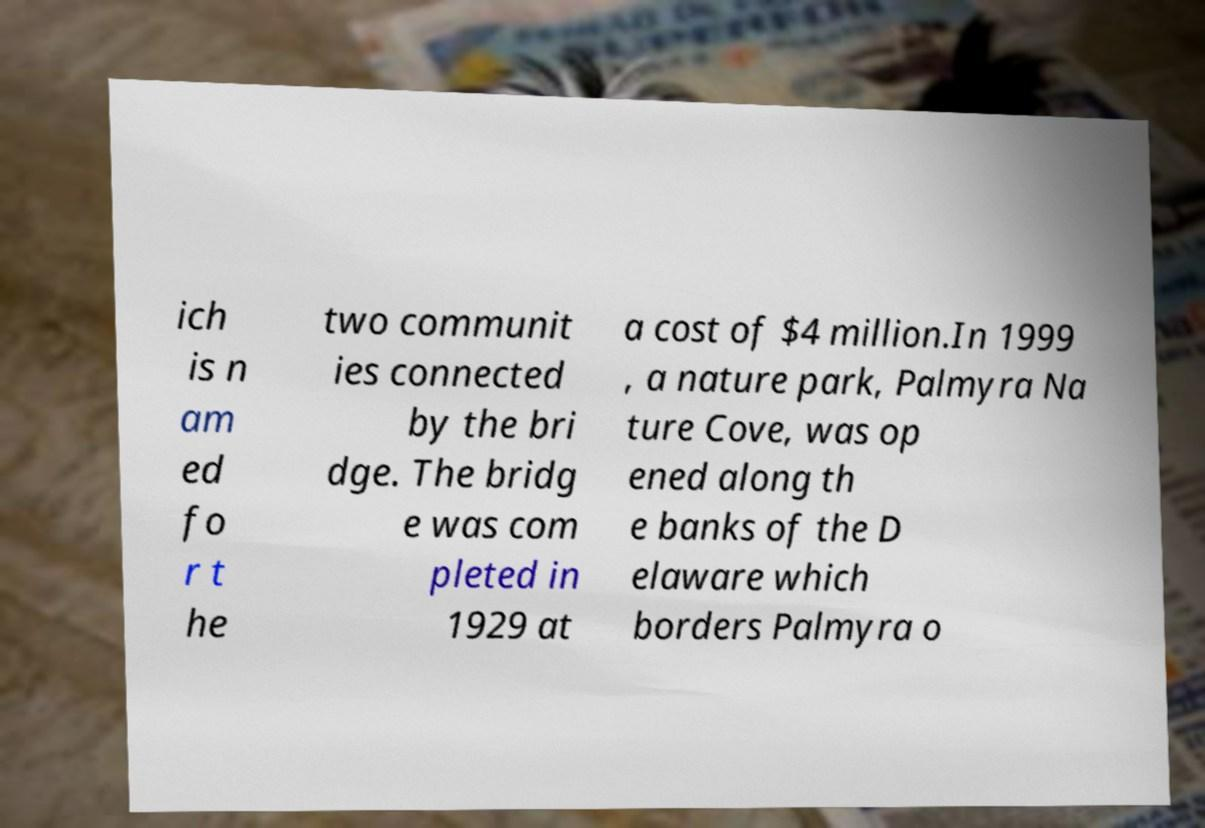I need the written content from this picture converted into text. Can you do that? ich is n am ed fo r t he two communit ies connected by the bri dge. The bridg e was com pleted in 1929 at a cost of $4 million.In 1999 , a nature park, Palmyra Na ture Cove, was op ened along th e banks of the D elaware which borders Palmyra o 